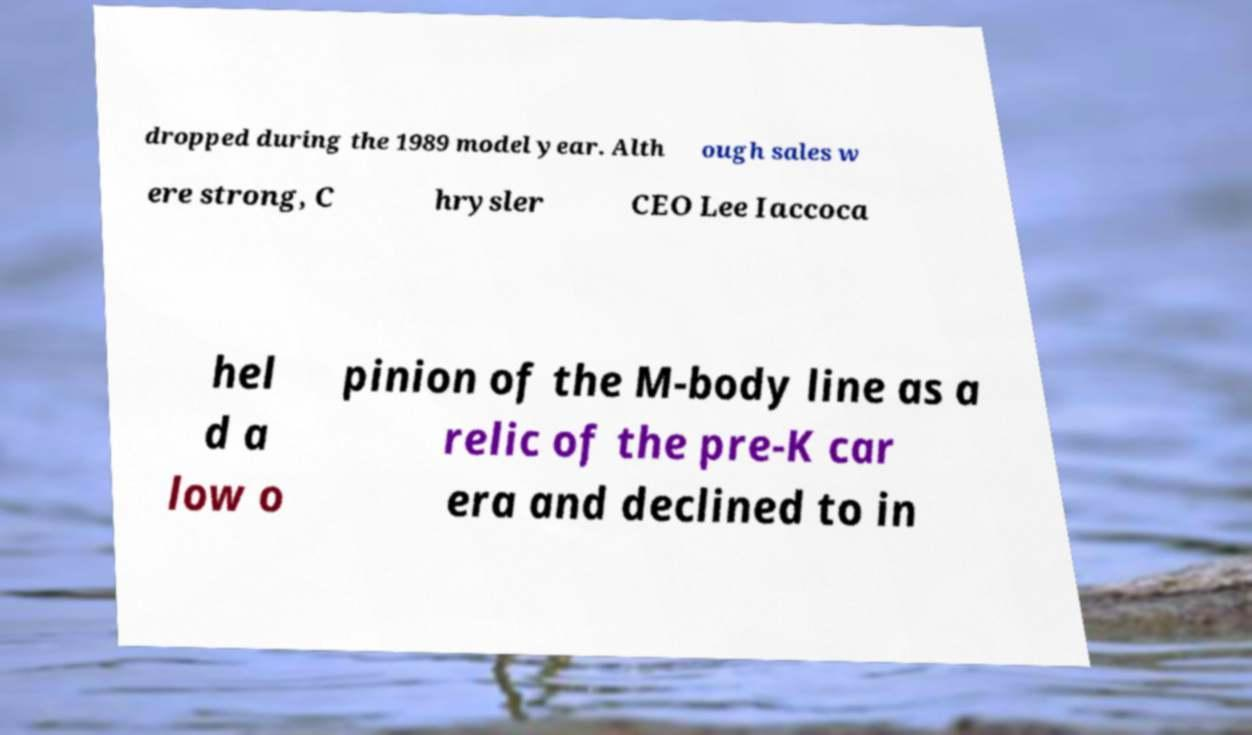What messages or text are displayed in this image? I need them in a readable, typed format. dropped during the 1989 model year. Alth ough sales w ere strong, C hrysler CEO Lee Iaccoca hel d a low o pinion of the M-body line as a relic of the pre-K car era and declined to in 